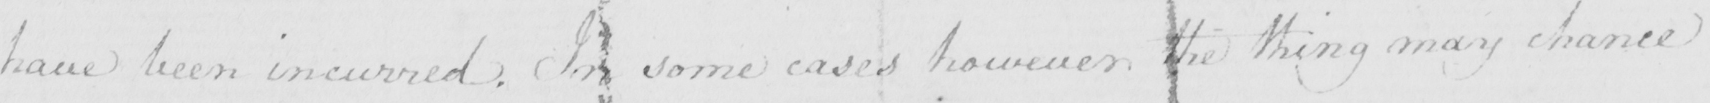Transcribe the text shown in this historical manuscript line. have been incurred . In some cases however the thing may chance 